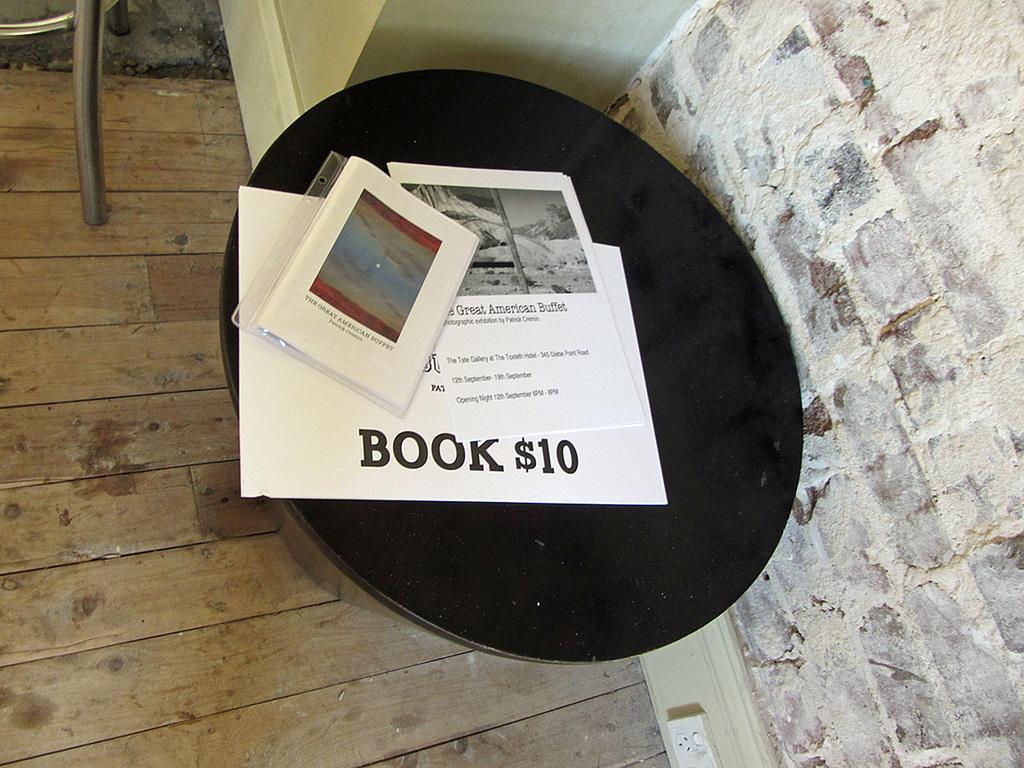How would you summarize this image in a sentence or two? In this picture I can see some papers and other objects on a black color table. On the right side I can see a wall. On the left side I can see an object on the floor. 